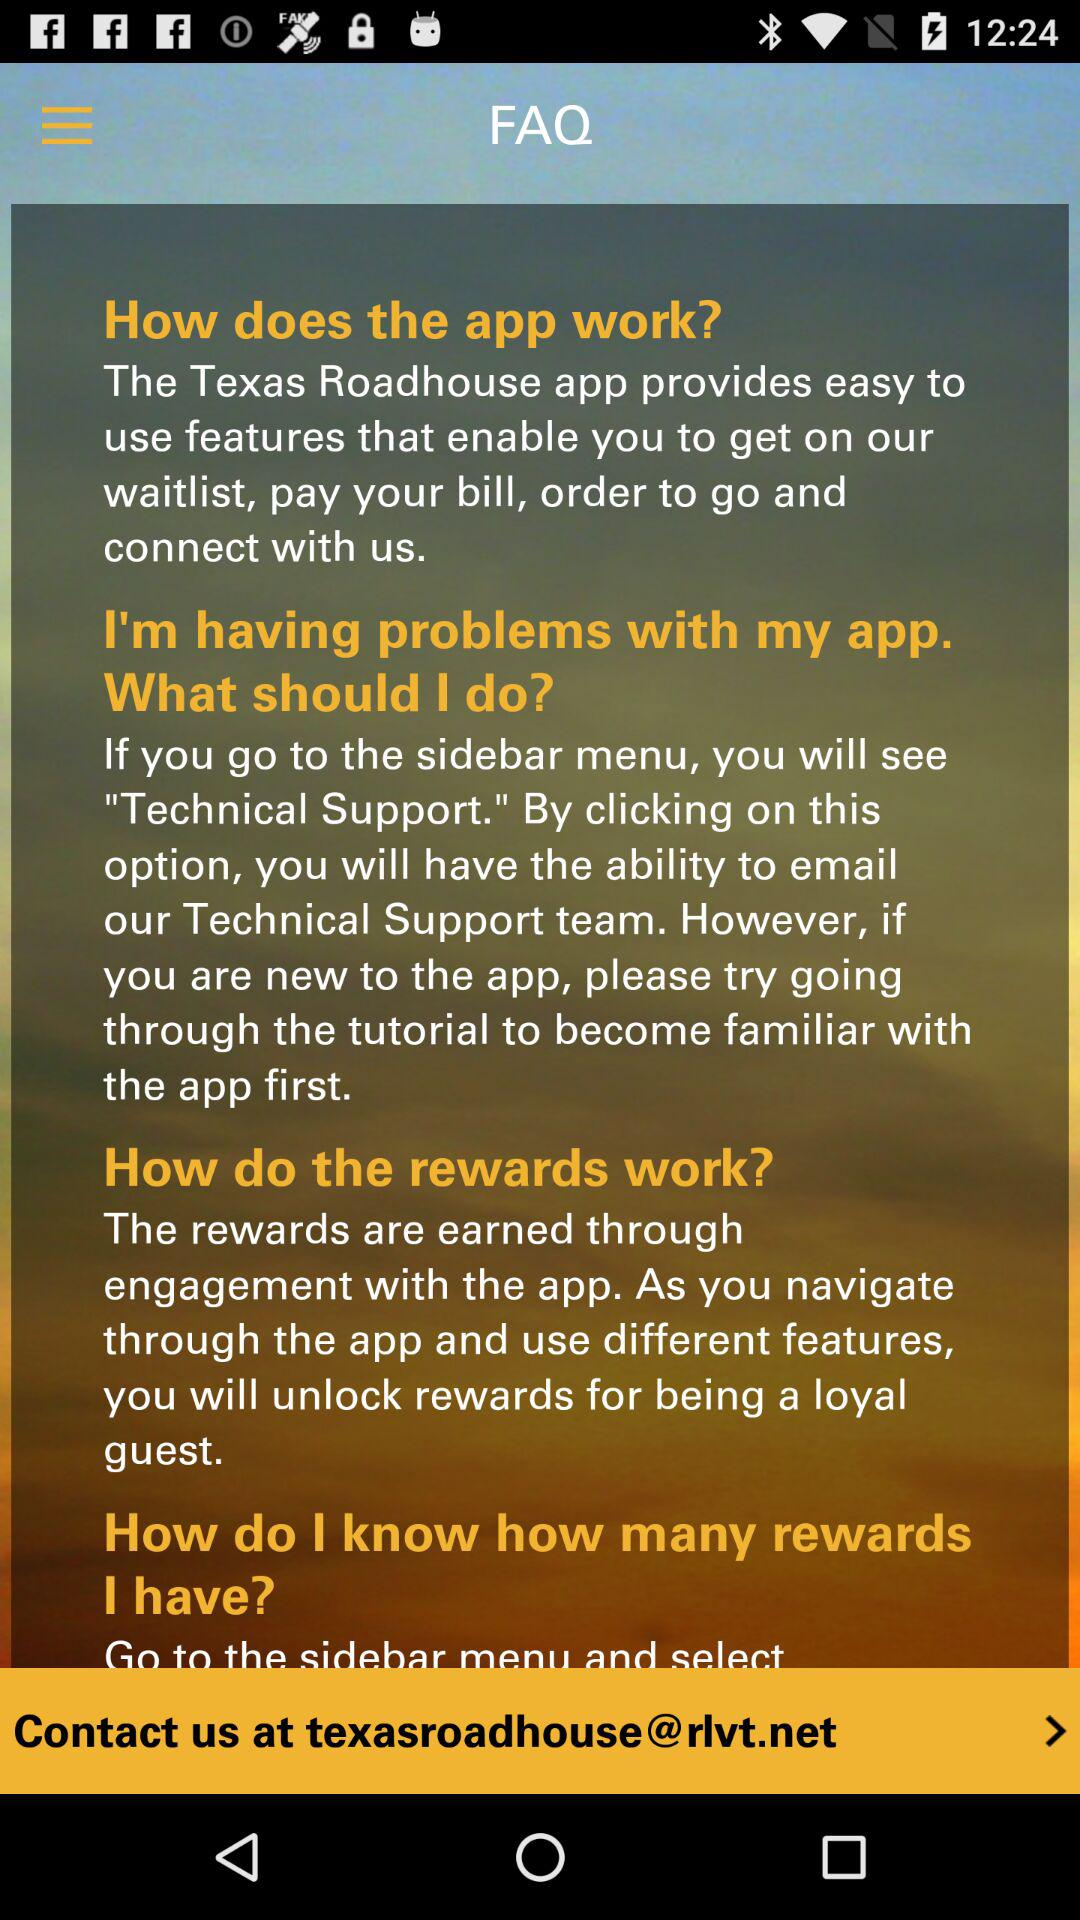What is the app name? The name of the app is "Texas Roadhouse". 